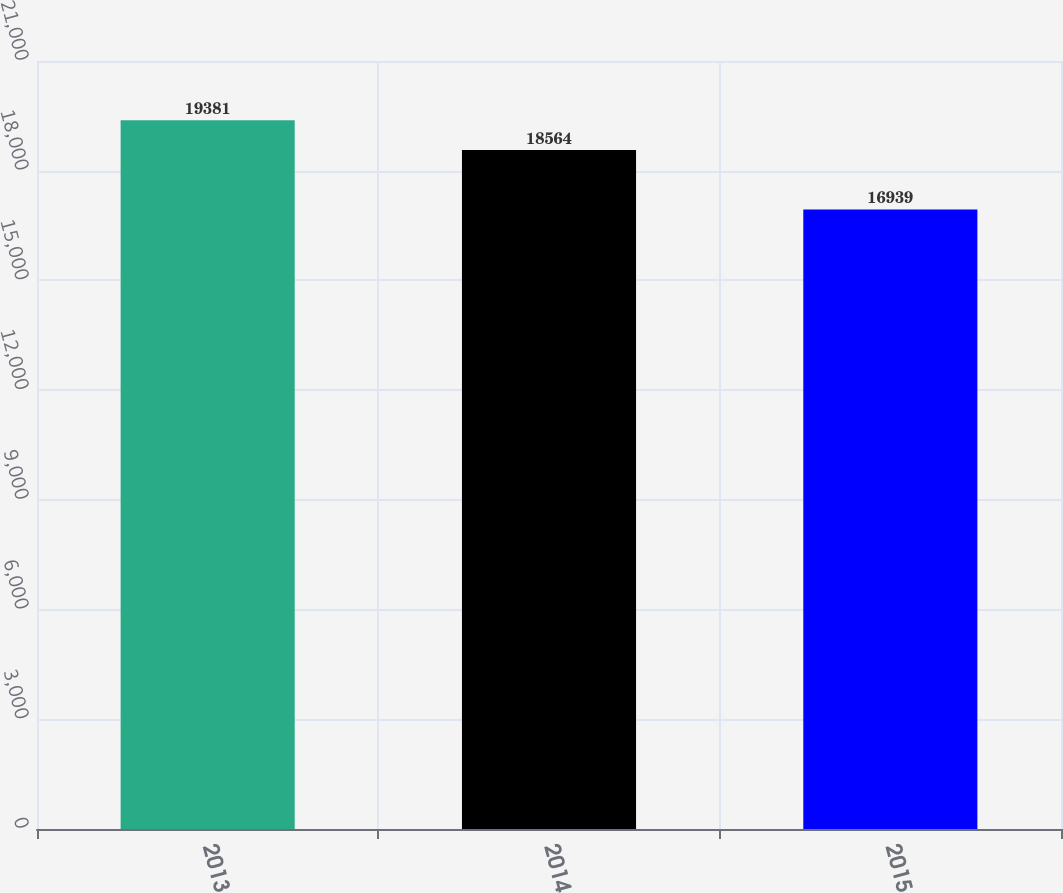Convert chart. <chart><loc_0><loc_0><loc_500><loc_500><bar_chart><fcel>2013<fcel>2014<fcel>2015<nl><fcel>19381<fcel>18564<fcel>16939<nl></chart> 